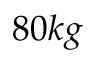Convert formula to latex. <formula><loc_0><loc_0><loc_500><loc_500>8 0 k g</formula> 